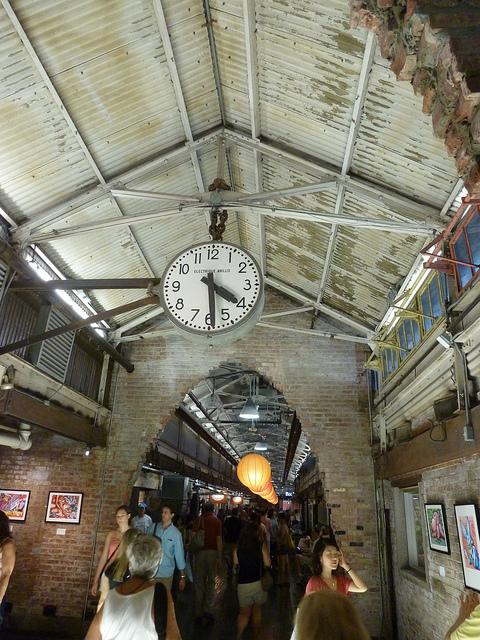What time is it approximately? four thirty 